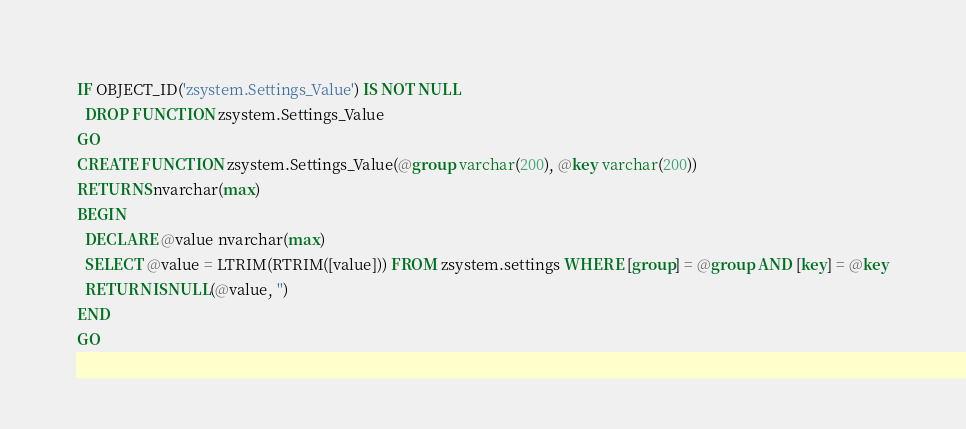Convert code to text. <code><loc_0><loc_0><loc_500><loc_500><_SQL_>
IF OBJECT_ID('zsystem.Settings_Value') IS NOT NULL
  DROP FUNCTION zsystem.Settings_Value
GO
CREATE FUNCTION zsystem.Settings_Value(@group varchar(200), @key varchar(200))
RETURNS nvarchar(max)
BEGIN
  DECLARE @value nvarchar(max)
  SELECT @value = LTRIM(RTRIM([value])) FROM zsystem.settings WHERE [group] = @group AND [key] = @key
  RETURN ISNULL(@value, '')
END
GO
</code> 